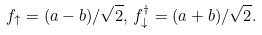<formula> <loc_0><loc_0><loc_500><loc_500>f _ { \uparrow } = ( a - b ) / \sqrt { 2 } , \, f ^ { \dagger } _ { \downarrow } = ( a + b ) / \sqrt { 2 } .</formula> 